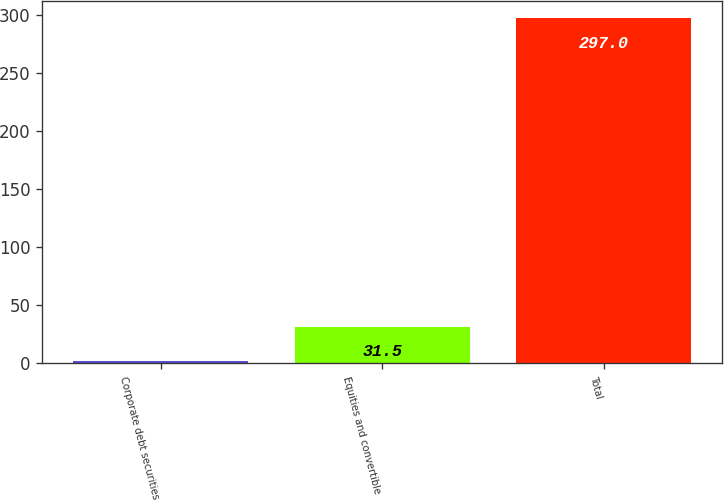Convert chart to OTSL. <chart><loc_0><loc_0><loc_500><loc_500><bar_chart><fcel>Corporate debt securities<fcel>Equities and convertible<fcel>Total<nl><fcel>2<fcel>31.5<fcel>297<nl></chart> 